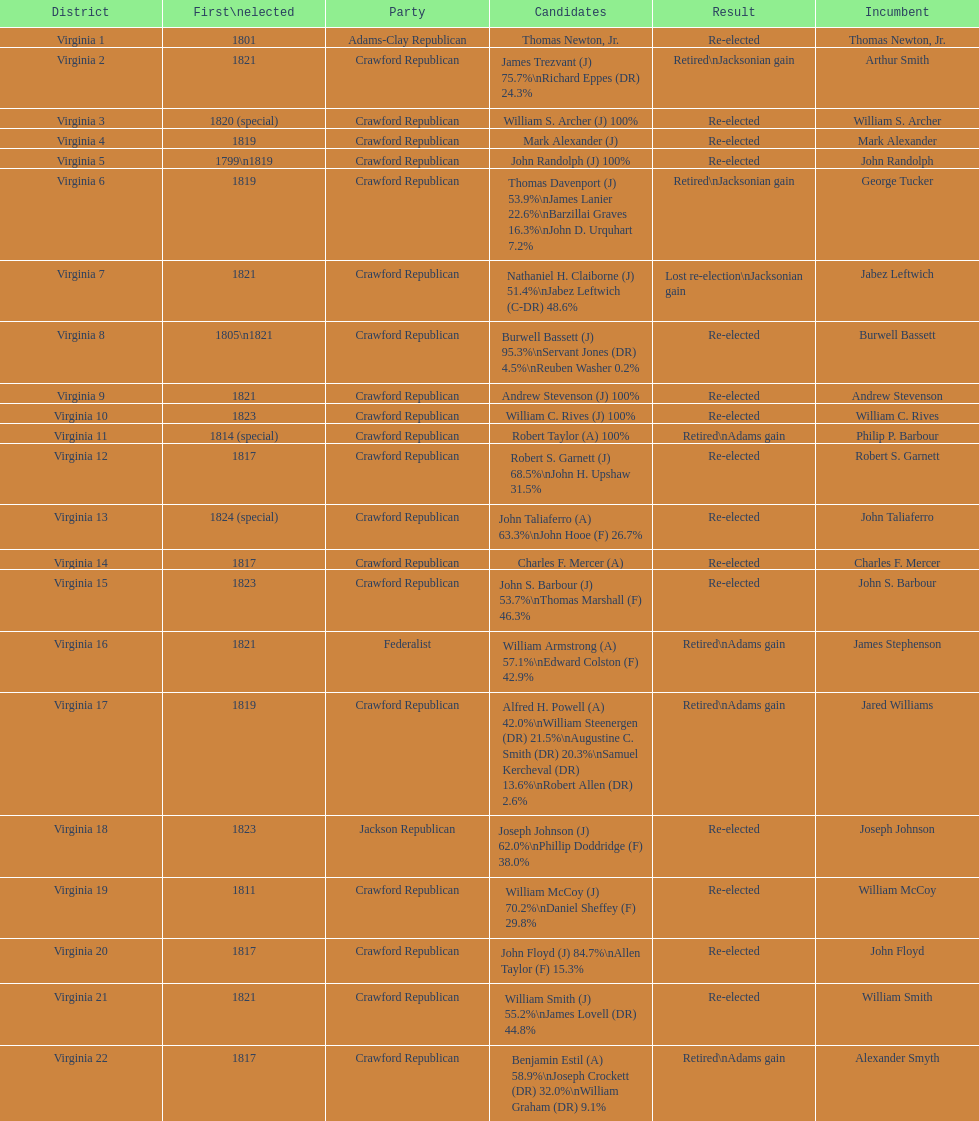Number of incumbents who retired or lost re-election 7. 